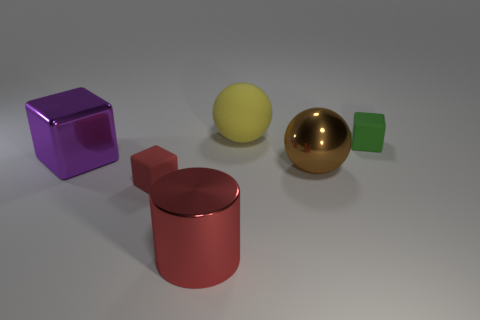Add 2 brown metallic objects. How many objects exist? 8 Subtract all balls. How many objects are left? 4 Add 4 big matte objects. How many big matte objects are left? 5 Add 1 cyan shiny objects. How many cyan shiny objects exist? 1 Subtract 0 cyan blocks. How many objects are left? 6 Subtract all yellow rubber objects. Subtract all metallic objects. How many objects are left? 2 